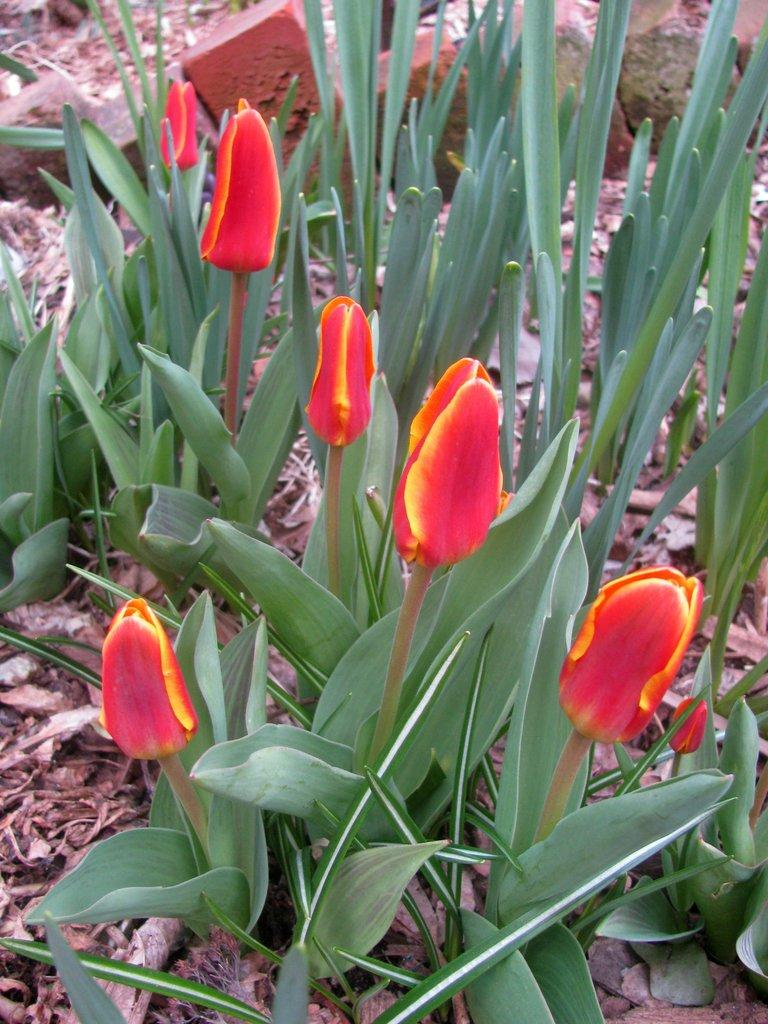What type of flowers are in the image? There are tulip flowers in the image. What are the characteristics of the tulip flowers? The tulip flowers have big leaves and are red in color. What can be seen in the background of the image? There are stones visible in the background of the image. How much money is the monkey holding in the image? There is no monkey or money present in the image; it features tulip flowers with big leaves and red color, along with stones in the background. 